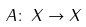Convert formula to latex. <formula><loc_0><loc_0><loc_500><loc_500>A \colon \, X \to X</formula> 